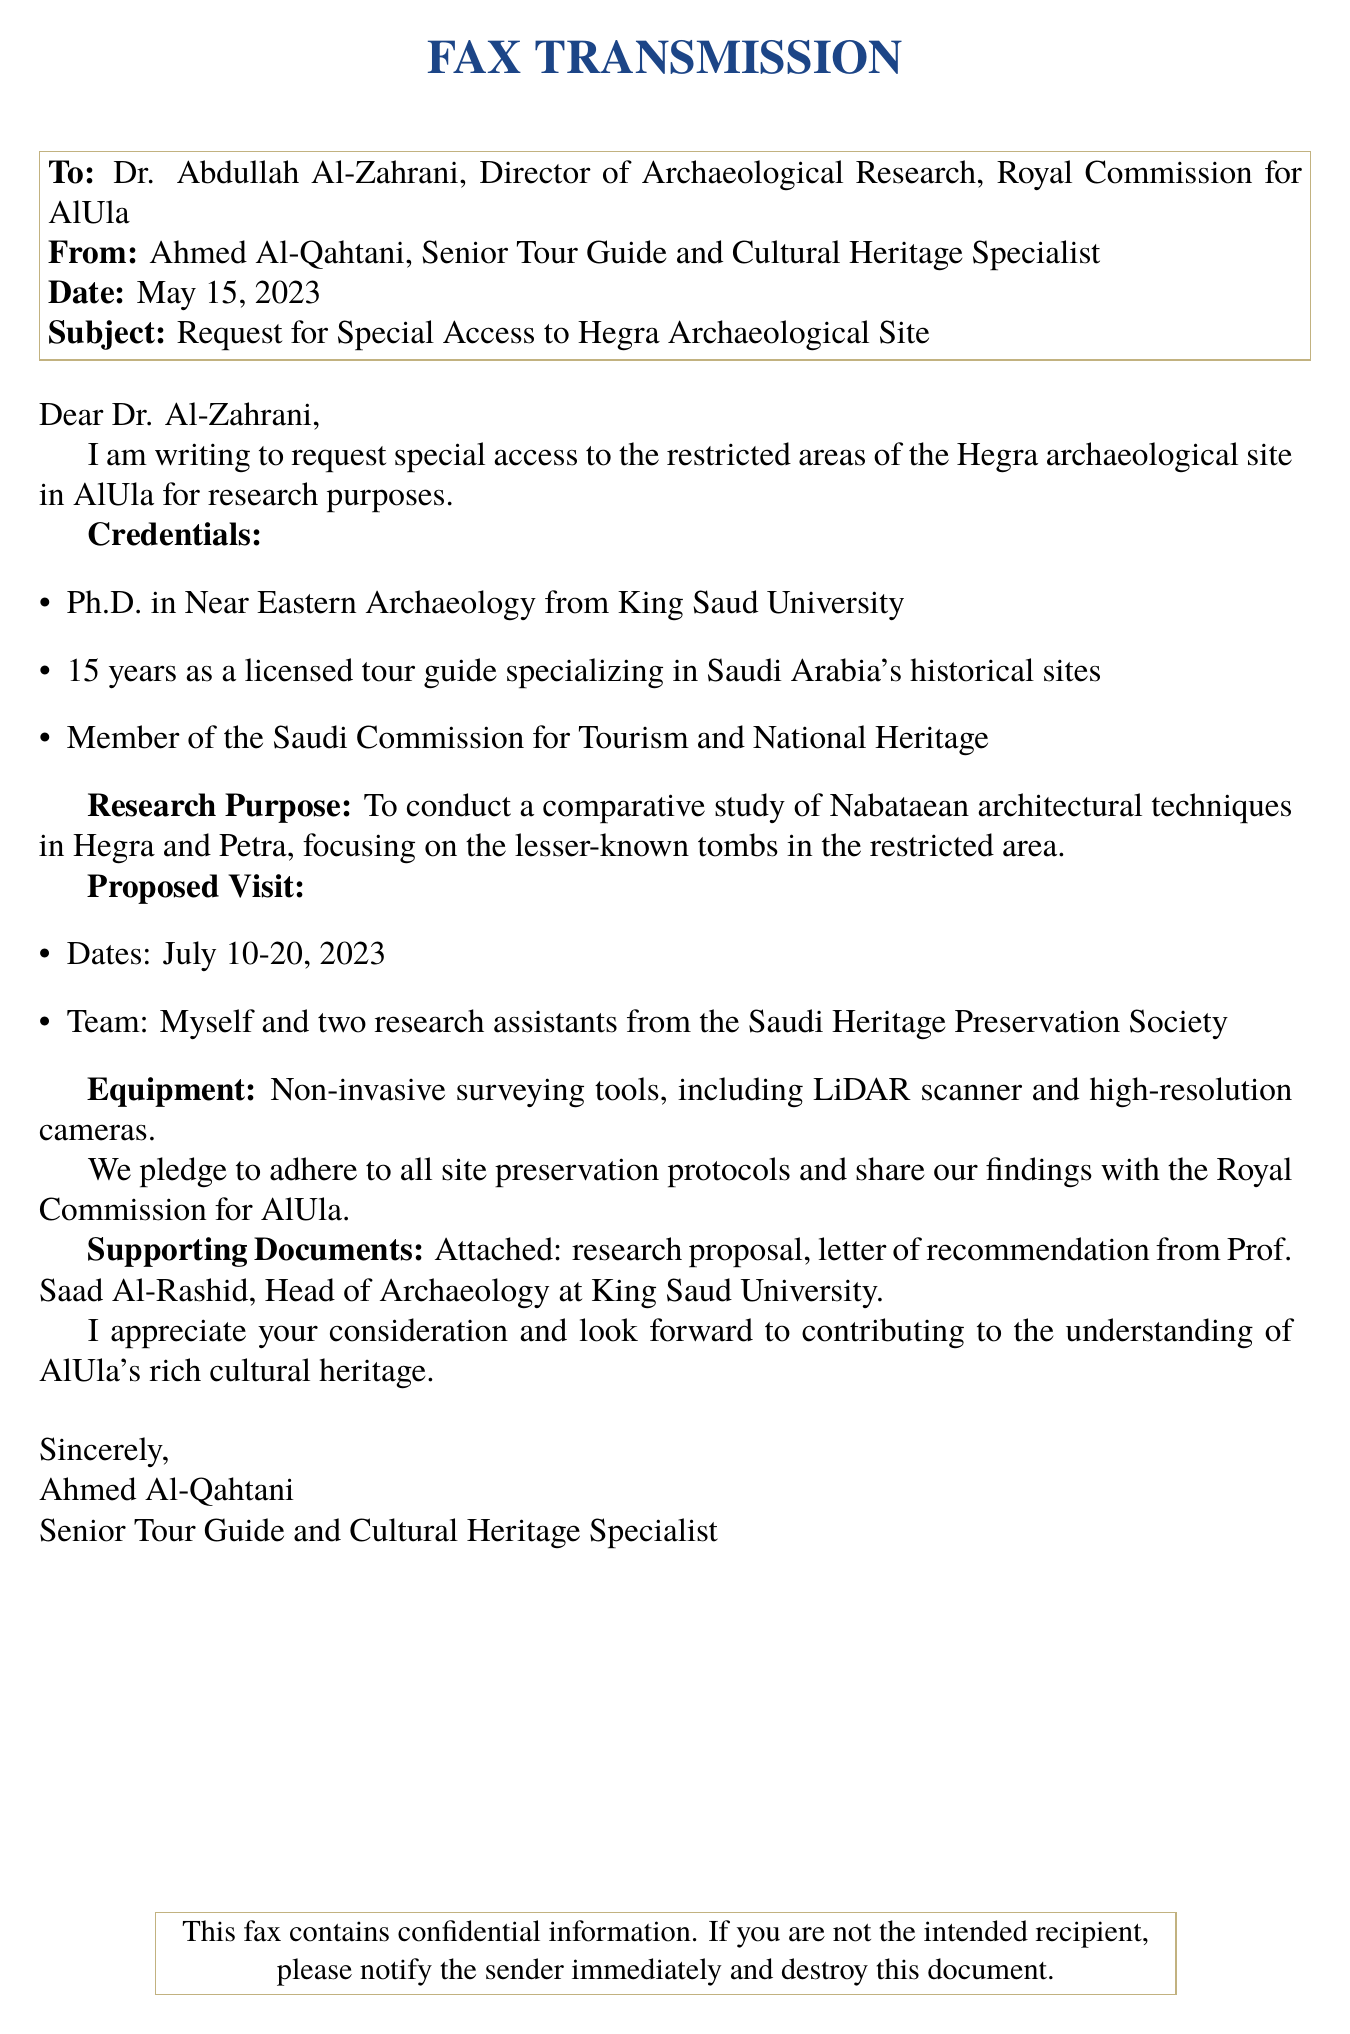What is the date of the fax? The date mentioned in the fax is May 15, 2023.
Answer: May 15, 2023 Who is the sender of the fax? The sender of the fax is Ahmed Al-Qahtani.
Answer: Ahmed Al-Qahtani What is the purpose of the visit? The purpose of the visit is to conduct a comparative study of Nabataean architectural techniques.
Answer: Comparative study of Nabataean architectural techniques How many research assistants will accompany the sender? The number of research assistants mentioned is two.
Answer: Two What equipment is mentioned for the research? The equipment mentioned includes a LiDAR scanner and high-resolution cameras.
Answer: LiDAR scanner and high-resolution cameras What are the proposed visit dates? The proposed visit dates provided in the fax are July 10-20, 2023.
Answer: July 10-20, 2023 What is the title of the recipient? The title of the recipient is Director of Archaeological Research.
Answer: Director of Archaeological Research What organization is the sender a member of? The sender is a member of the Saudi Commission for Tourism and National Heritage.
Answer: Saudi Commission for Tourism and National Heritage What is attached to the fax? The fax indicates that a research proposal and a letter of recommendation are attached.
Answer: Research proposal, letter of recommendation 